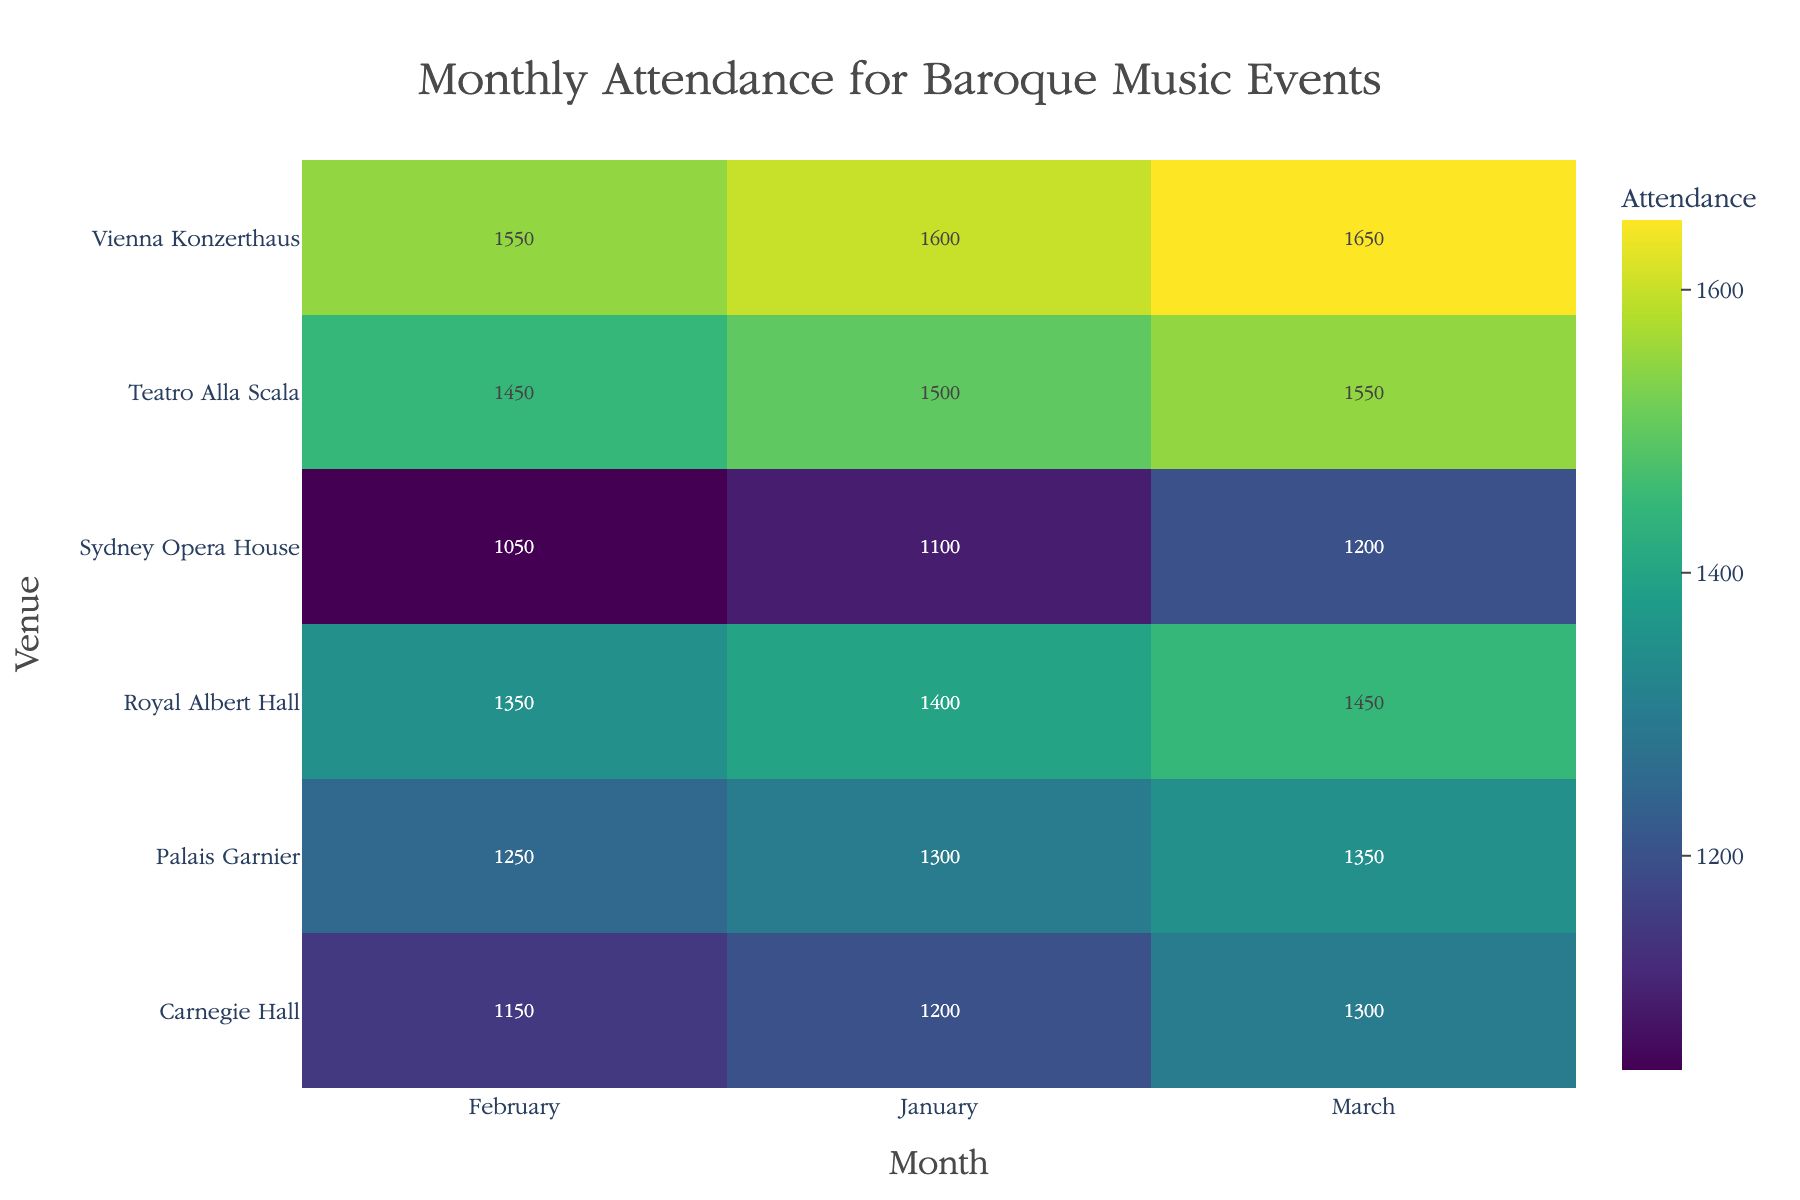Which venue has the highest attendance in January? Look for the highest value in the January column. The highest value is 1600 at the Vienna Konzerthaus.
Answer: Vienna Konzerthaus How does the attendance at the Sydney Opera House in February compare to March? Check the values for Sydney Opera House in February and March. February has 1050, and March has 1200. Compare the two values: 1200 is higher than 1050.
Answer: March is higher than February What is the total attendance for Carnegie Hall across all three months? Add the values of Carnegie Hall for January, February, and March. 1200 + 1150 + 1300 = 3650.
Answer: 3650 Which venue has the lowest attendance in any month, and what is the value? Find the smallest attendance value among all venues and months. The smallest value is 1050 at Sydney Opera House in February.
Answer: Sydney Opera House, 1050 Compare the average attendance of Royal Albert Hall and Palais Garnier across all three months. Which one has higher average attendance? Calculate the average attendance for both venues. Royal Albert Hall: (1400 + 1350 + 1450)/3 = 1400. Palais Garnier: (1300 + 1250 + 1350)/3 = 1300. Compare the two averages.
Answer: Royal Albert Hall What can you deduce about the variation in attendance across different venues? Look at the spread of values for each venue across the months. Teatro Alla Scala and Vienna Konzerthaus have consistently high values, while Sydney Opera House has lower and less varied attendance.
Answer: High variation among venues, with Teatro Alla Scala and Vienna Konzerthaus consistently high, Sydney Opera House lower Which month shows the highest overall attendance across all venues? Sum the attendance for all venues for each month: January (1200 + 1400 + 1100 + 1500 + 1300 + 1600) = 8100, February (1150 + 1350 + 1050 + 1450 + 1250 + 1550) = 7800, March (1300 + 1450 + 1200 + 1550 + 1350 + 1650) = 8500. Identify the highest sum.
Answer: March Is there any month where all venues have higher attendance compared to other months? Check attendance for each venue month-by-month: Compared to other months, March attendance is higher for all venues except Palais Garnier where February is higher than January but lower than March.
Answer: No 